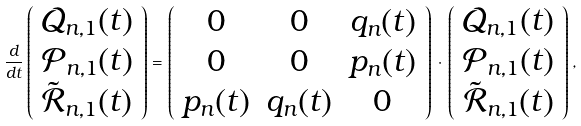Convert formula to latex. <formula><loc_0><loc_0><loc_500><loc_500>\frac { d } { d t } \left ( \begin{array} { c } \mathcal { Q } _ { n , 1 } ( t ) \\ \mathcal { P } _ { n , 1 } ( t ) \\ \tilde { \mathcal { R } } _ { n , 1 } ( t ) \\ \end{array} \right ) = \left ( \begin{array} { c c c } 0 & 0 & q _ { n } ( t ) \\ 0 & 0 & p _ { n } ( t ) \\ p _ { n } ( t ) & q _ { n } ( t ) & 0 \\ \end{array} \right ) \, \cdot \, \left ( \begin{array} { c } \mathcal { Q } _ { n , 1 } ( t ) \\ \mathcal { P } _ { n , 1 } ( t ) \\ \tilde { \mathcal { R } } _ { n , 1 } ( t ) \\ \end{array} \right ) ,</formula> 